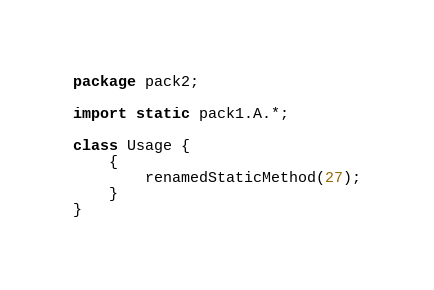<code> <loc_0><loc_0><loc_500><loc_500><_Java_>package pack2;

import static pack1.A.*;

class Usage {
    {
        renamedStaticMethod(27);
    }
}</code> 